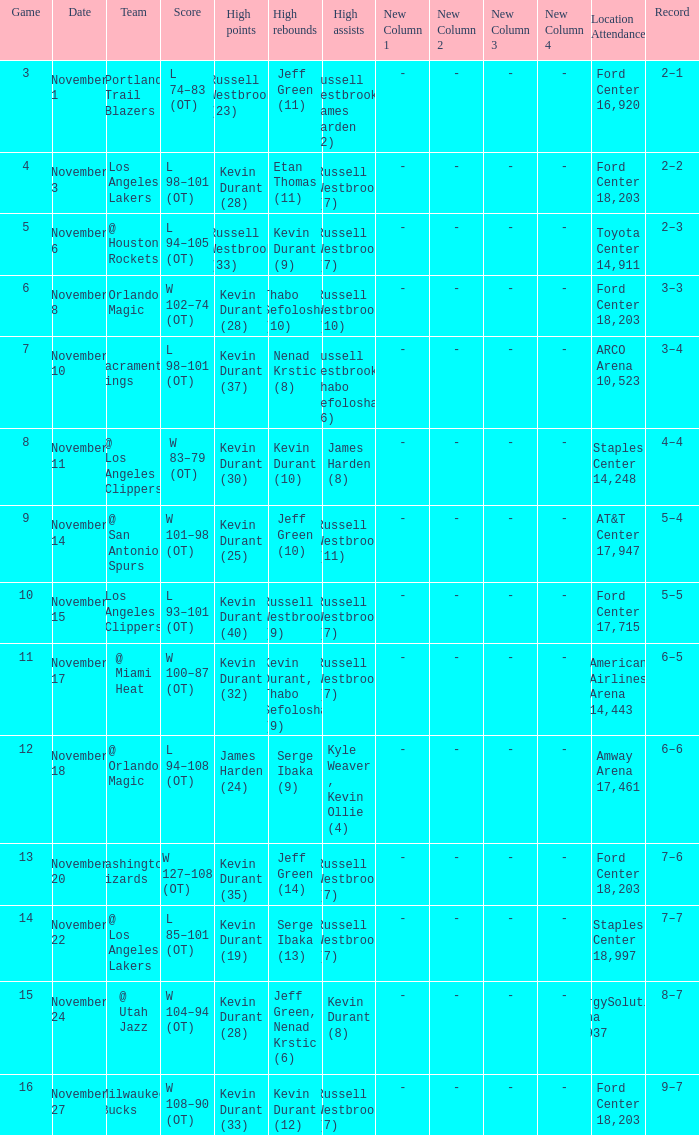When was the game number 3 played? November 1. 